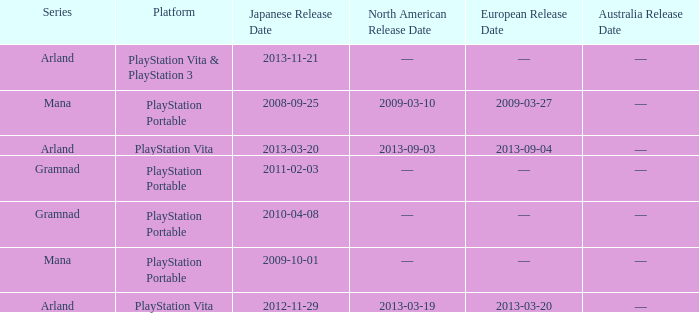Could you parse the entire table as a dict? {'header': ['Series', 'Platform', 'Japanese Release Date', 'North American Release Date', 'European Release Date', 'Australia Release Date'], 'rows': [['Arland', 'PlayStation Vita & PlayStation 3', '2013-11-21', '—', '—', '—'], ['Mana', 'PlayStation Portable', '2008-09-25', '2009-03-10', '2009-03-27', '—'], ['Arland', 'PlayStation Vita', '2013-03-20', '2013-09-03', '2013-09-04', '—'], ['Gramnad', 'PlayStation Portable', '2011-02-03', '—', '—', '—'], ['Gramnad', 'PlayStation Portable', '2010-04-08', '—', '—', '—'], ['Mana', 'PlayStation Portable', '2009-10-01', '—', '—', '—'], ['Arland', 'PlayStation Vita', '2012-11-29', '2013-03-19', '2013-03-20', '—']]} What is the North American release date of the remake with a European release date on 2013-03-20? 2013-03-19. 